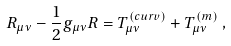<formula> <loc_0><loc_0><loc_500><loc_500>R _ { \mu \nu } - \frac { 1 } { 2 } g _ { \mu \nu } R = T _ { \mu \nu } ^ { ( c u r v ) } + T _ { \mu \nu } ^ { ( m ) } \, ,</formula> 